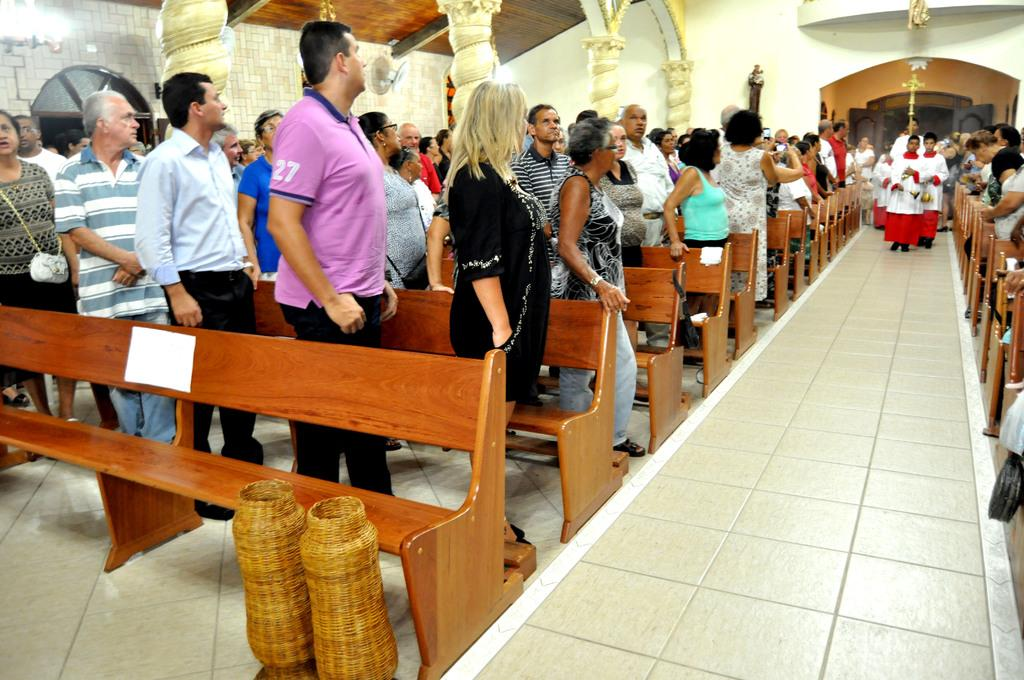What is the setting of the image? The image is set in a church. What are the people in the image doing? People are standing in the church. Can you describe any specific features of the church? There is a path in the church, and priests are walking on the path. Additionally, there are pillars and walls in the church. What type of waves can be seen crashing against the walls of the church in the image? There are no waves present in the image; it is set inside a church. What kind of machine is being used by the priests in the image? There is no machine being used by the priests in the image; they are simply walking on the path. 